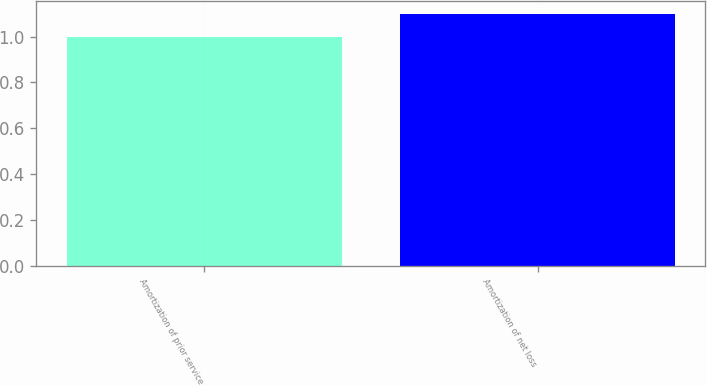<chart> <loc_0><loc_0><loc_500><loc_500><bar_chart><fcel>Amortization of prior service<fcel>Amortization of net loss<nl><fcel>1<fcel>1.1<nl></chart> 